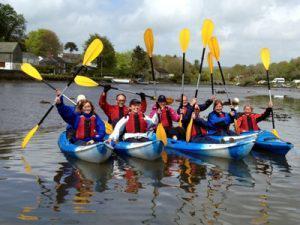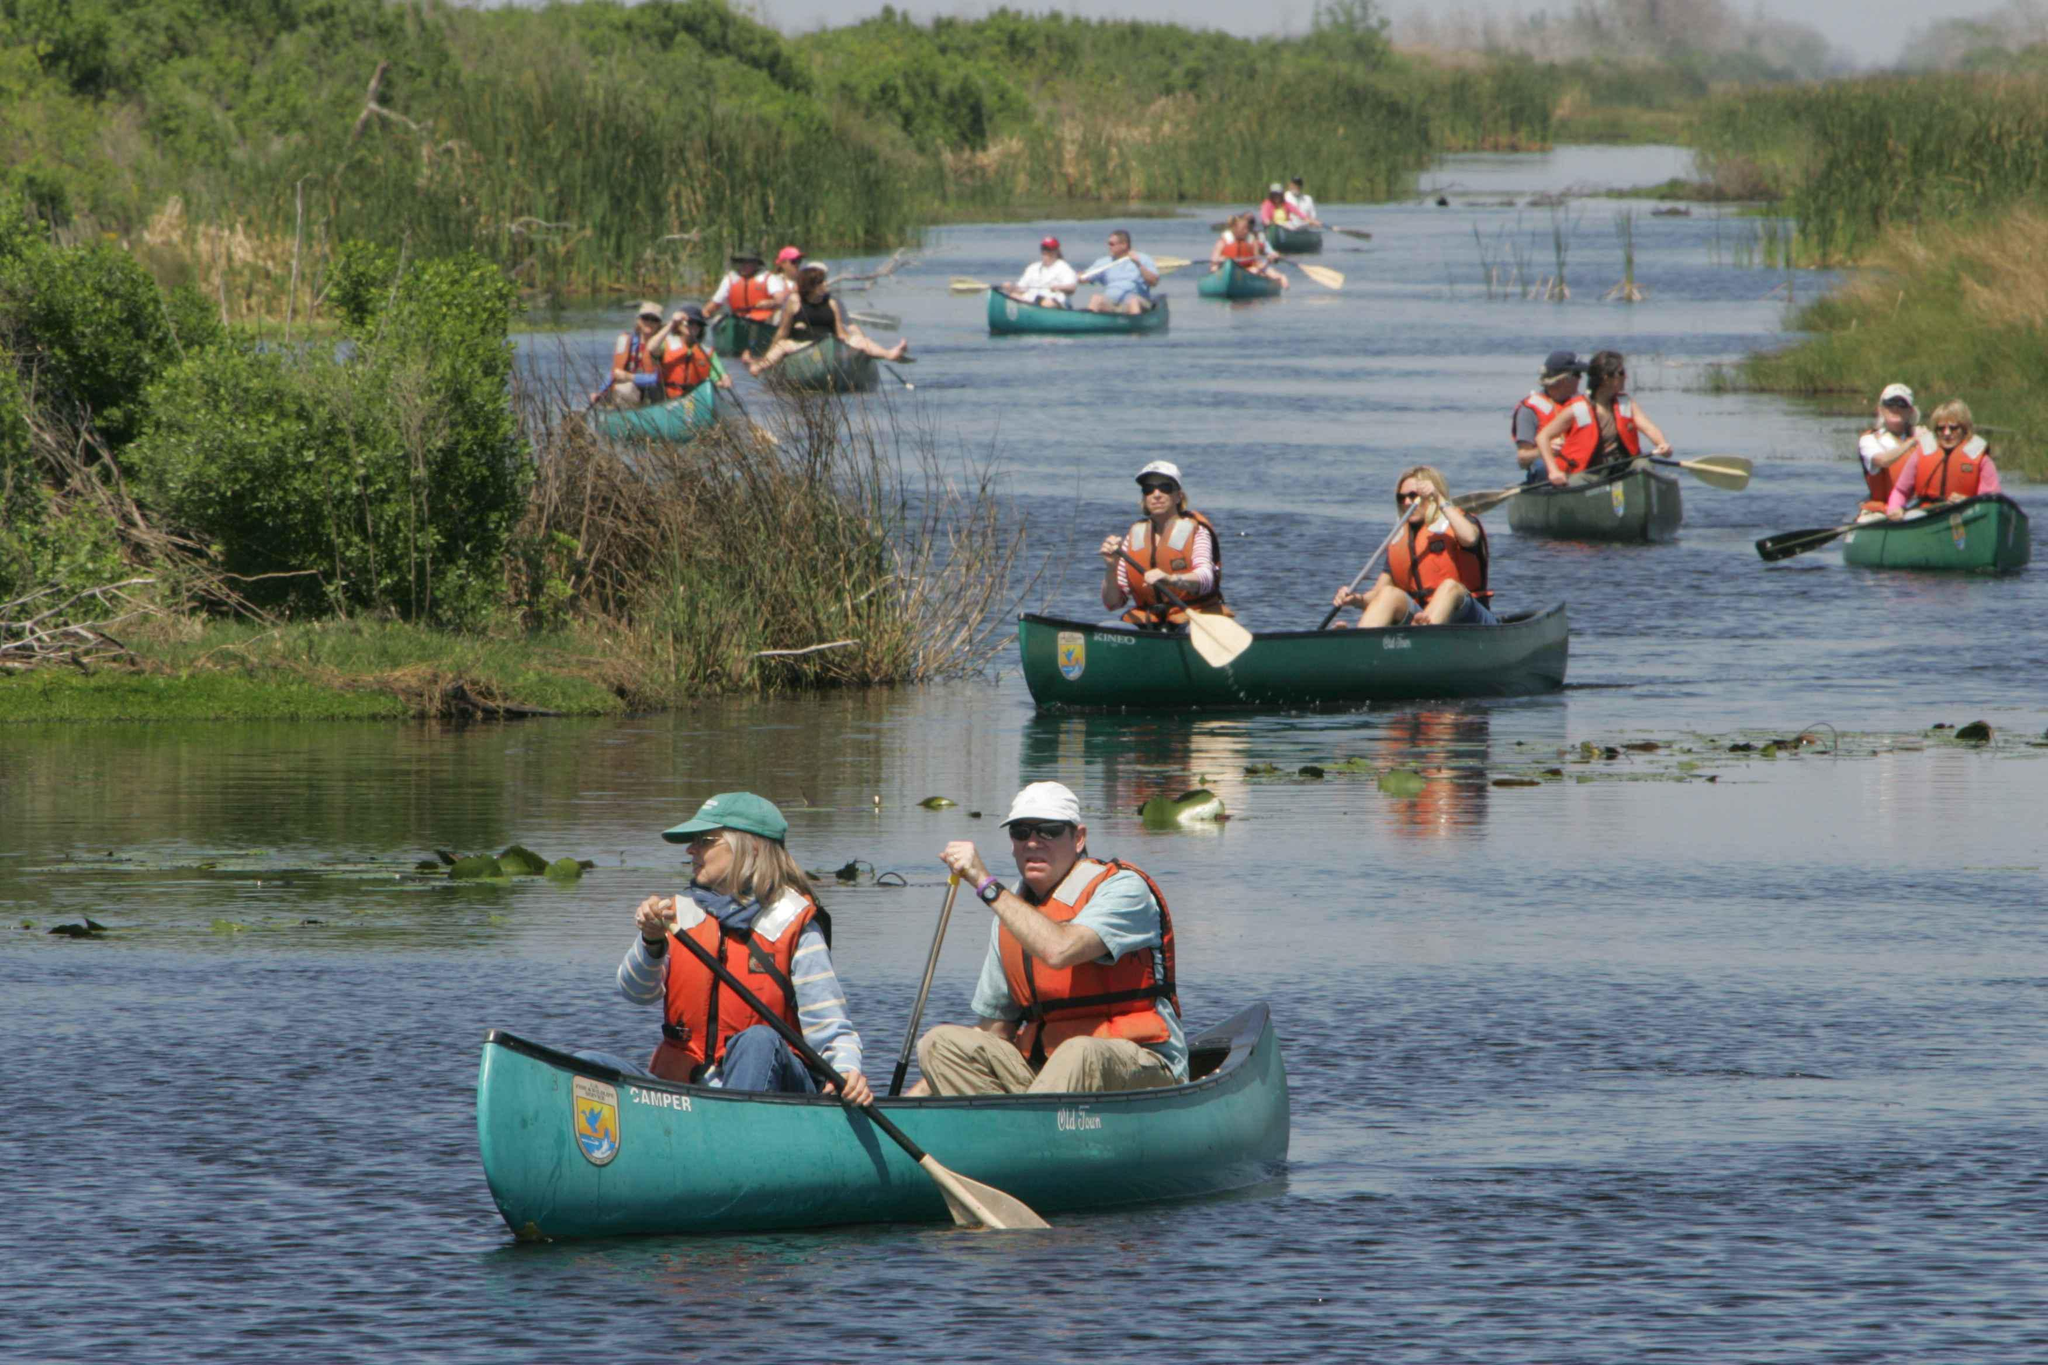The first image is the image on the left, the second image is the image on the right. Considering the images on both sides, is "One image shows a row of forward-facing canoes featuring the same color and containing people with arms raised." valid? Answer yes or no. Yes. The first image is the image on the left, the second image is the image on the right. Evaluate the accuracy of this statement regarding the images: "A group of people are in canoes with their hands in the air.". Is it true? Answer yes or no. Yes. 